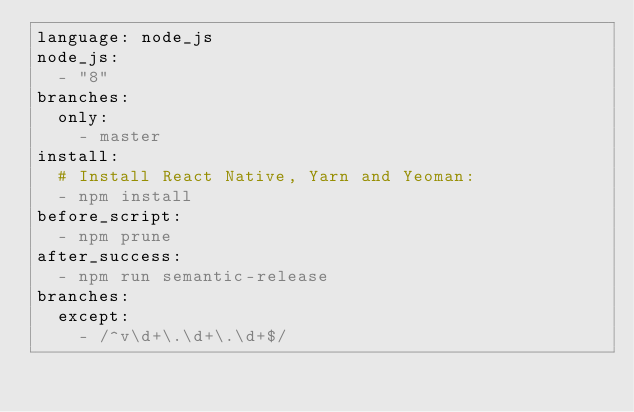<code> <loc_0><loc_0><loc_500><loc_500><_YAML_>language: node_js
node_js:
  - "8"
branches:
  only:
    - master
install:
  # Install React Native, Yarn and Yeoman:
  - npm install
before_script:
  - npm prune
after_success:
  - npm run semantic-release
branches:
  except:
    - /^v\d+\.\d+\.\d+$/
</code> 